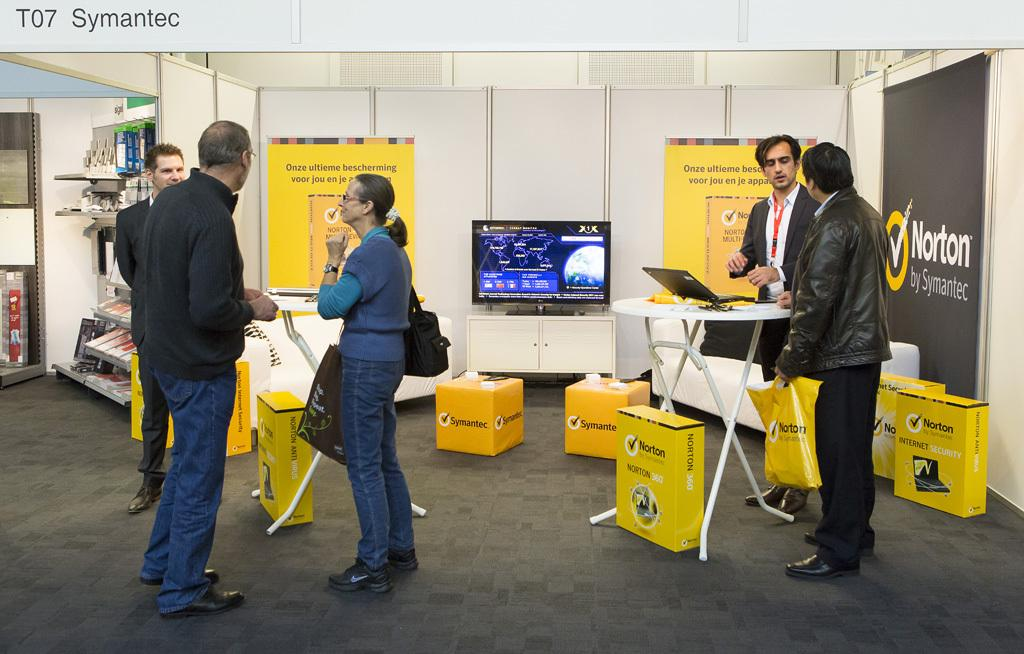What is the color of the wall in the image? The wall in the image is white. What can be seen on the wall in the image? There are shelves on the wall in the image. What decorations are present in the image? Banners are present in the image. What objects are visible on the shelves in the image? Boxes are visible on the shelves in the image. What furniture is in the image? Tables are in the image. What type of screen is in the image? There is a screen in the image. What electronic device is present in the image? A laptop is present in the image. Who is in the image? There are people in the image. What type of coat is hanging on the screen in the image? There is no coat present in the image, and the screen is not a place where a coat would typically hang. Can you hear the people talking in the image? The image is a still picture, so we cannot hear any sounds or conversations. 